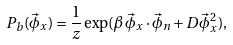Convert formula to latex. <formula><loc_0><loc_0><loc_500><loc_500>P _ { b } ( \vec { \phi } _ { x } ) = \frac { 1 } { z } \exp ( \beta \, \vec { \phi } _ { x } \cdot \vec { \phi } _ { n } + D \vec { \phi } _ { x } ^ { 2 } ) ,</formula> 